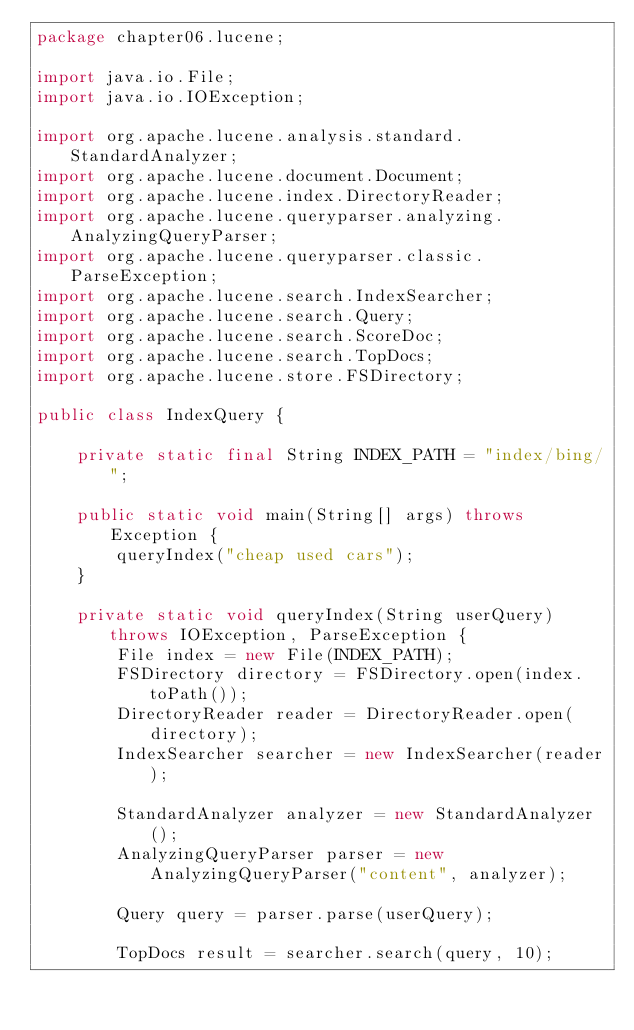<code> <loc_0><loc_0><loc_500><loc_500><_Java_>package chapter06.lucene;

import java.io.File;
import java.io.IOException;

import org.apache.lucene.analysis.standard.StandardAnalyzer;
import org.apache.lucene.document.Document;
import org.apache.lucene.index.DirectoryReader;
import org.apache.lucene.queryparser.analyzing.AnalyzingQueryParser;
import org.apache.lucene.queryparser.classic.ParseException;
import org.apache.lucene.search.IndexSearcher;
import org.apache.lucene.search.Query;
import org.apache.lucene.search.ScoreDoc;
import org.apache.lucene.search.TopDocs;
import org.apache.lucene.store.FSDirectory;

public class IndexQuery {

    private static final String INDEX_PATH = "index/bing/";

    public static void main(String[] args) throws Exception {
        queryIndex("cheap used cars");
    }

    private static void queryIndex(String userQuery) throws IOException, ParseException {
        File index = new File(INDEX_PATH);
        FSDirectory directory = FSDirectory.open(index.toPath());
        DirectoryReader reader = DirectoryReader.open(directory);
        IndexSearcher searcher = new IndexSearcher(reader);

        StandardAnalyzer analyzer = new StandardAnalyzer();
        AnalyzingQueryParser parser = new AnalyzingQueryParser("content", analyzer);

        Query query = parser.parse(userQuery);

        TopDocs result = searcher.search(query, 10);</code> 